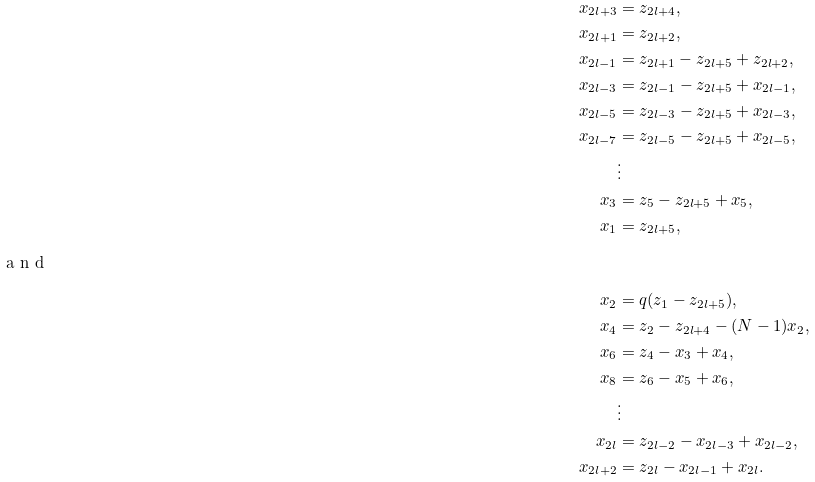Convert formula to latex. <formula><loc_0><loc_0><loc_500><loc_500>x _ { 2 l + 3 } & = z _ { 2 l + 4 } , \\ x _ { 2 l + 1 } & = z _ { 2 l + 2 } , \\ x _ { 2 l - 1 } & = z _ { 2 l + 1 } - z _ { 2 l + 5 } + z _ { 2 l + 2 } , \\ x _ { 2 l - 3 } & = z _ { 2 l - 1 } - z _ { 2 l + 5 } + x _ { 2 l - 1 } , \\ x _ { 2 l - 5 } & = z _ { 2 l - 3 } - z _ { 2 l + 5 } + x _ { 2 l - 3 } , \\ x _ { 2 l - 7 } & = z _ { 2 l - 5 } - z _ { 2 l + 5 } + x _ { 2 l - 5 } , \\ & \vdots \\ x _ { 3 } & = z _ { 5 } - z _ { 2 l + 5 } + x _ { 5 } , \\ x _ { 1 } & = z _ { 2 l + 5 } , \\ \intertext { a n d } x _ { 2 } & = q ( z _ { 1 } - z _ { 2 l + 5 } ) , \\ x _ { 4 } & = z _ { 2 } - z _ { 2 l + 4 } - ( N - 1 ) x _ { 2 } , \\ x _ { 6 } & = z _ { 4 } - x _ { 3 } + x _ { 4 } , \\ x _ { 8 } & = z _ { 6 } - x _ { 5 } + x _ { 6 } , \\ & \vdots \\ x _ { 2 l } & = z _ { 2 l - 2 } - x _ { 2 l - 3 } + x _ { 2 l - 2 } , \\ x _ { 2 l + 2 } & = z _ { 2 l } - x _ { 2 l - 1 } + x _ { 2 l } .</formula> 